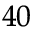<formula> <loc_0><loc_0><loc_500><loc_500>^ { 4 0 }</formula> 